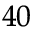<formula> <loc_0><loc_0><loc_500><loc_500>^ { 4 0 }</formula> 